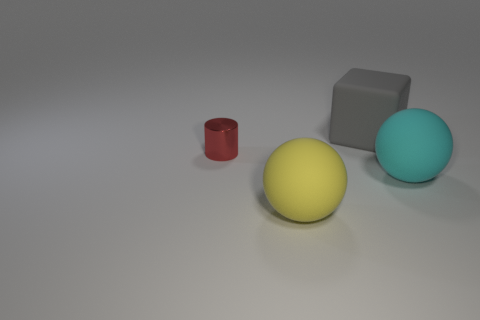What number of large yellow rubber cubes are there?
Offer a very short reply. 0. There is a big gray object that is made of the same material as the yellow thing; what is its shape?
Make the answer very short. Cube. What size is the sphere that is behind the large sphere left of the large rubber block?
Your answer should be very brief. Large. How many objects are large matte objects that are behind the red thing or objects behind the yellow sphere?
Provide a succinct answer. 3. Is the number of matte balls less than the number of cubes?
Ensure brevity in your answer.  No. What number of things are either small shiny cylinders or small brown metallic balls?
Your answer should be very brief. 1. Does the tiny red metal thing have the same shape as the yellow object?
Make the answer very short. No. Are there any other things that are the same material as the tiny cylinder?
Keep it short and to the point. No. There is a rubber thing behind the red shiny thing; is its size the same as the matte sphere that is on the right side of the yellow matte ball?
Offer a terse response. Yes. What material is the object that is on the right side of the small red shiny thing and behind the cyan rubber ball?
Your answer should be very brief. Rubber. 